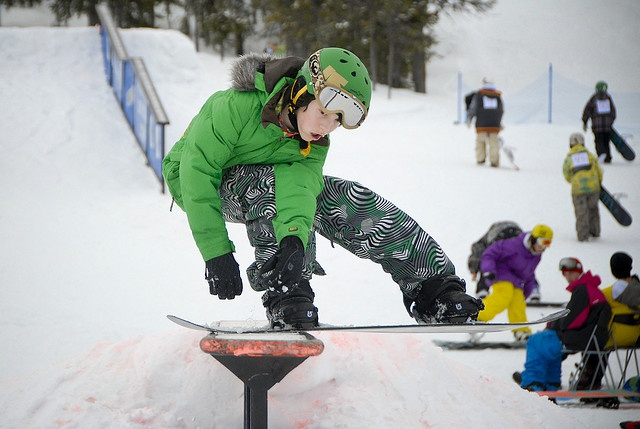Describe the objects in this image and their specific colors. I can see people in black, green, gray, and darkgreen tones, people in black, blue, navy, and maroon tones, people in black, purple, olive, gold, and navy tones, people in black, gray, olive, and darkgreen tones, and people in black, olive, and darkgray tones in this image. 